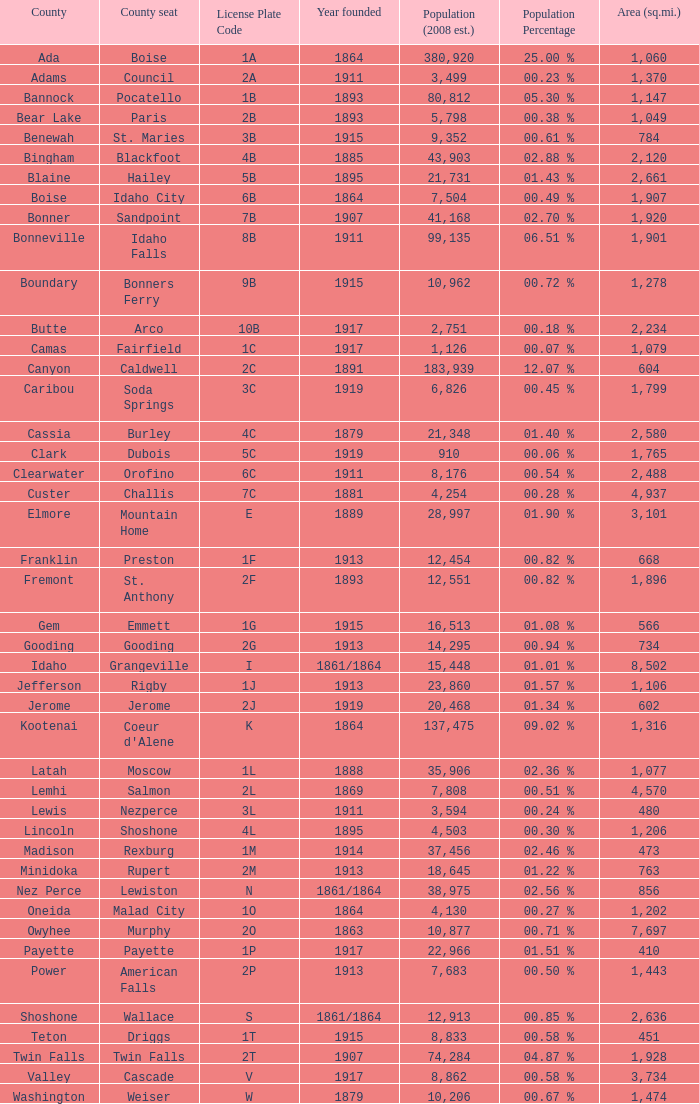What is the country seat for the license plate code 5c? Dubois. 